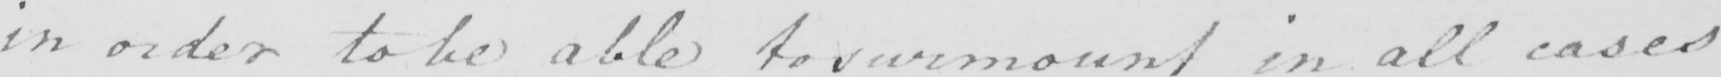What text is written in this handwritten line? in order to be able to surmount in all cases 